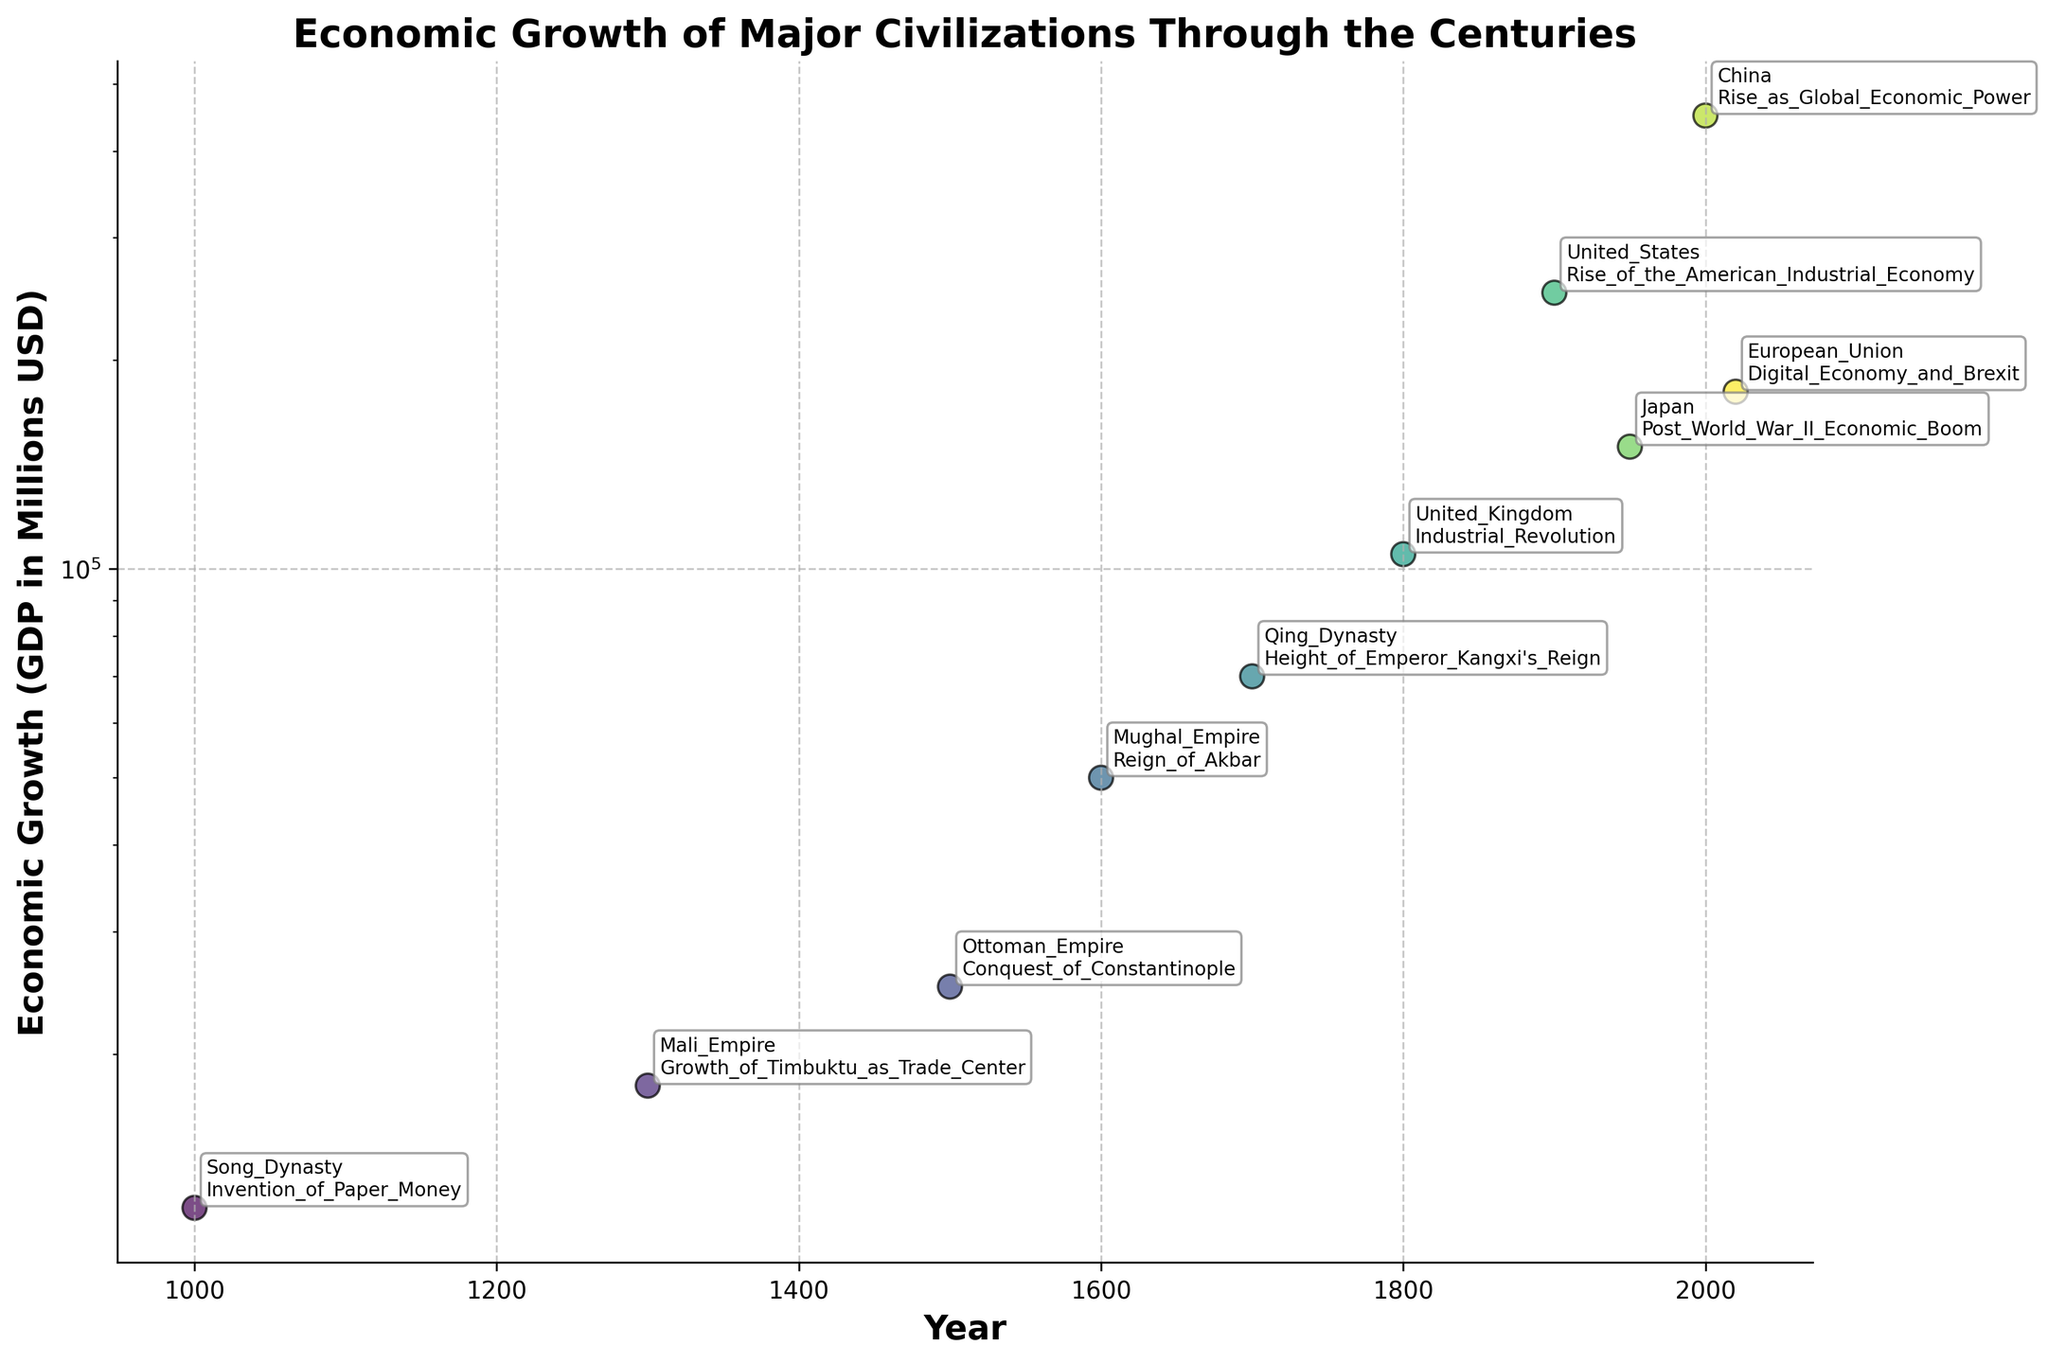What is the title of the figure? The title of the figure is often placed at the top of the plot and is typically the largest and boldest text element.
Answer: Economic Growth of Major Civilizations Through the Centuries What does the y-axis represent? The y-axis label tells us what is being measured. It should be labeled around the vertical axis.
Answer: Economic Growth (GDP in Millions USD) Which civilization experienced the highest economic growth in the year 2000? Look for the data point corresponding to the year 2000 and identify the associated civilization.
Answer: China How many civilizations are represented in the figure? Count the unique labels of civilizations shown in the scatterplot annotations or legend.
Answer: 10 What historical event is associated with the United Kingdom in the figure? Identify the data point for United Kingdom and check the annotation for the associated historical event.
Answer: Industrial Revolution Which civilization witnessed higher economic growth, the Ottoman Empire in 1500 or the Mughal Empire in 1600? Compare the data points for the Ottoman Empire in 1500 and the Mughal Empire in 1600 by looking at their respective GDP values.
Answer: Mughal Empire In which year did Japan experience significant economic growth according to the plot? Look for the data point annotated with "Post World War II Economic Boom" which corresponds to Japan.
Answer: 1950 How does the economic growth of China in 2000 compare to the United States in 1900? Compare the GDP values for China in 2000 and the United States in 1900.
Answer: China's GDP in 2000 is higher than that of the United States in 1900 What is the overall trend in economic growth over the centuries as depicted in the figure? Observe the pattern of GDP values from the earlier centuries to the recent years to identify the trend.
Answer: Increasing Between which years did the Qing Dynasty experience economic growth? Identify the data points marked with the Qing Dynasty to find the corresponding years.
Answer: 1700 